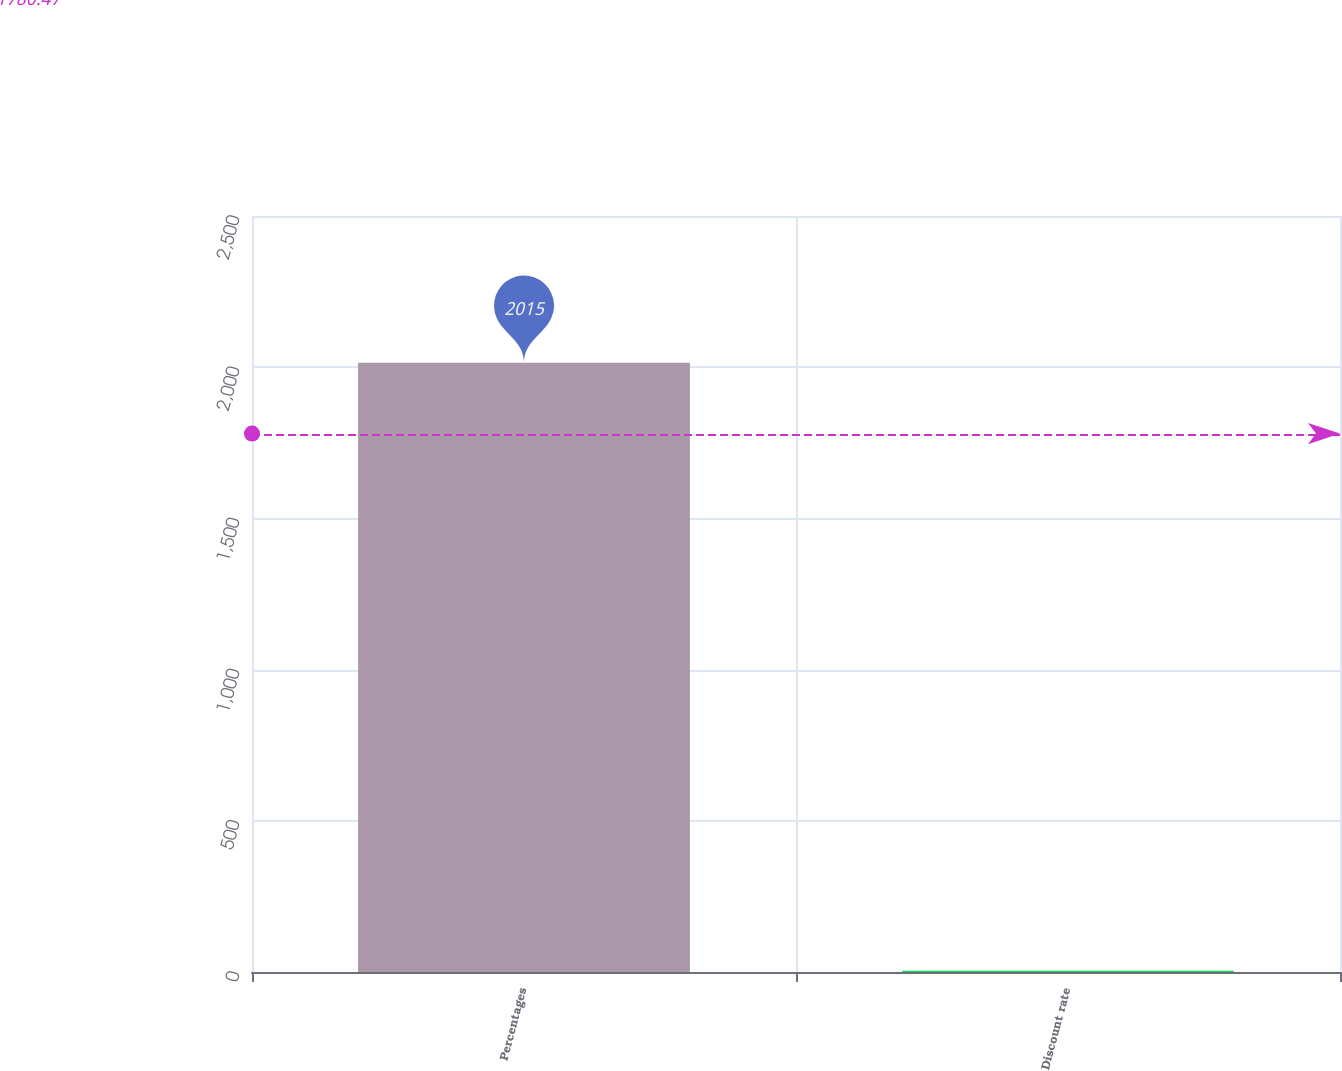<chart> <loc_0><loc_0><loc_500><loc_500><bar_chart><fcel>Percentages<fcel>Discount rate<nl><fcel>2015<fcel>4.16<nl></chart> 